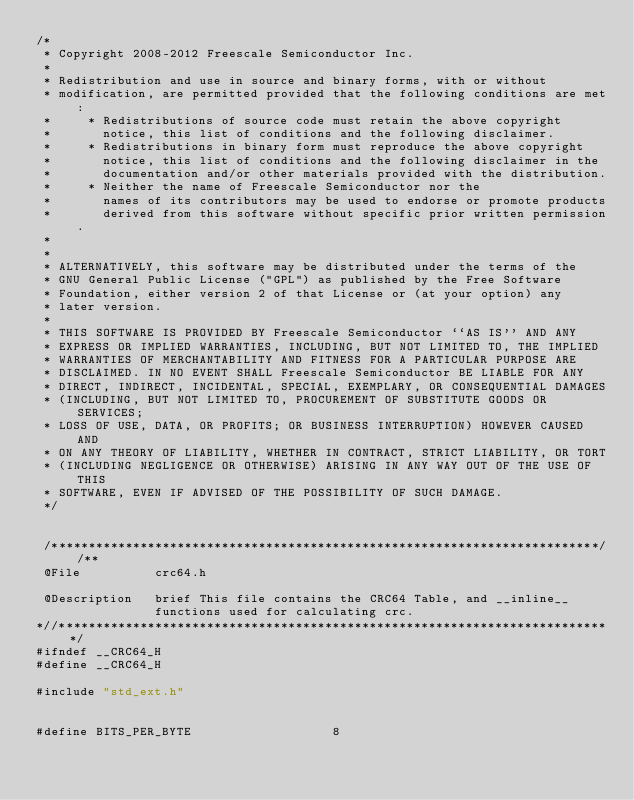<code> <loc_0><loc_0><loc_500><loc_500><_C_>/*
 * Copyright 2008-2012 Freescale Semiconductor Inc.
 *
 * Redistribution and use in source and binary forms, with or without
 * modification, are permitted provided that the following conditions are met:
 *     * Redistributions of source code must retain the above copyright
 *       notice, this list of conditions and the following disclaimer.
 *     * Redistributions in binary form must reproduce the above copyright
 *       notice, this list of conditions and the following disclaimer in the
 *       documentation and/or other materials provided with the distribution.
 *     * Neither the name of Freescale Semiconductor nor the
 *       names of its contributors may be used to endorse or promote products
 *       derived from this software without specific prior written permission.
 *
 *
 * ALTERNATIVELY, this software may be distributed under the terms of the
 * GNU General Public License ("GPL") as published by the Free Software
 * Foundation, either version 2 of that License or (at your option) any
 * later version.
 *
 * THIS SOFTWARE IS PROVIDED BY Freescale Semiconductor ``AS IS'' AND ANY
 * EXPRESS OR IMPLIED WARRANTIES, INCLUDING, BUT NOT LIMITED TO, THE IMPLIED
 * WARRANTIES OF MERCHANTABILITY AND FITNESS FOR A PARTICULAR PURPOSE ARE
 * DISCLAIMED. IN NO EVENT SHALL Freescale Semiconductor BE LIABLE FOR ANY
 * DIRECT, INDIRECT, INCIDENTAL, SPECIAL, EXEMPLARY, OR CONSEQUENTIAL DAMAGES
 * (INCLUDING, BUT NOT LIMITED TO, PROCUREMENT OF SUBSTITUTE GOODS OR SERVICES;
 * LOSS OF USE, DATA, OR PROFITS; OR BUSINESS INTERRUPTION) HOWEVER CAUSED AND
 * ON ANY THEORY OF LIABILITY, WHETHER IN CONTRACT, STRICT LIABILITY, OR TORT
 * (INCLUDING NEGLIGENCE OR OTHERWISE) ARISING IN ANY WAY OUT OF THE USE OF THIS
 * SOFTWARE, EVEN IF ADVISED OF THE POSSIBILITY OF SUCH DAMAGE.
 */


 /**************************************************************************//**
 @File          crc64.h

 @Description   brief This file contains the CRC64 Table, and __inline__
                functions used for calculating crc.
*//***************************************************************************/
#ifndef __CRC64_H
#define __CRC64_H

#include "std_ext.h"


#define BITS_PER_BYTE                   8
</code> 